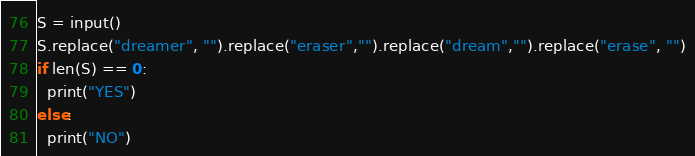Convert code to text. <code><loc_0><loc_0><loc_500><loc_500><_Python_>S = input()
S.replace("dreamer", "").replace("eraser","").replace("dream","").replace("erase", "")
if len(S) == 0:
  print("YES")
else:
  print("NO")
</code> 